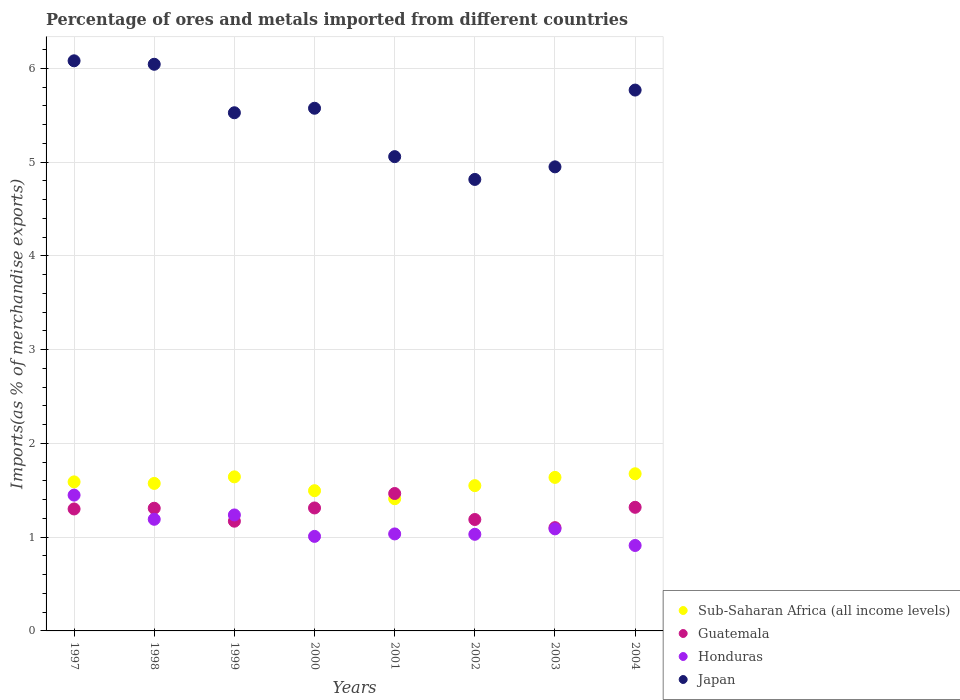What is the percentage of imports to different countries in Japan in 1999?
Provide a short and direct response. 5.53. Across all years, what is the maximum percentage of imports to different countries in Guatemala?
Ensure brevity in your answer.  1.47. Across all years, what is the minimum percentage of imports to different countries in Sub-Saharan Africa (all income levels)?
Ensure brevity in your answer.  1.41. In which year was the percentage of imports to different countries in Japan maximum?
Provide a short and direct response. 1997. In which year was the percentage of imports to different countries in Japan minimum?
Offer a terse response. 2002. What is the total percentage of imports to different countries in Guatemala in the graph?
Offer a terse response. 10.16. What is the difference between the percentage of imports to different countries in Japan in 1999 and that in 2001?
Offer a very short reply. 0.47. What is the difference between the percentage of imports to different countries in Honduras in 2004 and the percentage of imports to different countries in Japan in 1997?
Offer a terse response. -5.17. What is the average percentage of imports to different countries in Honduras per year?
Give a very brief answer. 1.12. In the year 2004, what is the difference between the percentage of imports to different countries in Honduras and percentage of imports to different countries in Sub-Saharan Africa (all income levels)?
Make the answer very short. -0.76. In how many years, is the percentage of imports to different countries in Sub-Saharan Africa (all income levels) greater than 1.6 %?
Keep it short and to the point. 3. What is the ratio of the percentage of imports to different countries in Honduras in 1998 to that in 2001?
Your answer should be compact. 1.15. Is the difference between the percentage of imports to different countries in Honduras in 2000 and 2002 greater than the difference between the percentage of imports to different countries in Sub-Saharan Africa (all income levels) in 2000 and 2002?
Your answer should be compact. Yes. What is the difference between the highest and the second highest percentage of imports to different countries in Honduras?
Make the answer very short. 0.21. What is the difference between the highest and the lowest percentage of imports to different countries in Japan?
Provide a succinct answer. 1.27. In how many years, is the percentage of imports to different countries in Honduras greater than the average percentage of imports to different countries in Honduras taken over all years?
Provide a succinct answer. 3. Is the sum of the percentage of imports to different countries in Japan in 1997 and 2004 greater than the maximum percentage of imports to different countries in Honduras across all years?
Your answer should be very brief. Yes. Is the percentage of imports to different countries in Japan strictly greater than the percentage of imports to different countries in Sub-Saharan Africa (all income levels) over the years?
Ensure brevity in your answer.  Yes. Is the percentage of imports to different countries in Sub-Saharan Africa (all income levels) strictly less than the percentage of imports to different countries in Honduras over the years?
Provide a short and direct response. No. How many years are there in the graph?
Give a very brief answer. 8. Are the values on the major ticks of Y-axis written in scientific E-notation?
Your response must be concise. No. Does the graph contain any zero values?
Ensure brevity in your answer.  No. Where does the legend appear in the graph?
Provide a short and direct response. Bottom right. How many legend labels are there?
Make the answer very short. 4. What is the title of the graph?
Ensure brevity in your answer.  Percentage of ores and metals imported from different countries. Does "Mali" appear as one of the legend labels in the graph?
Make the answer very short. No. What is the label or title of the X-axis?
Provide a succinct answer. Years. What is the label or title of the Y-axis?
Your answer should be compact. Imports(as % of merchandise exports). What is the Imports(as % of merchandise exports) in Sub-Saharan Africa (all income levels) in 1997?
Make the answer very short. 1.59. What is the Imports(as % of merchandise exports) in Guatemala in 1997?
Make the answer very short. 1.3. What is the Imports(as % of merchandise exports) of Honduras in 1997?
Your answer should be very brief. 1.45. What is the Imports(as % of merchandise exports) in Japan in 1997?
Keep it short and to the point. 6.08. What is the Imports(as % of merchandise exports) in Sub-Saharan Africa (all income levels) in 1998?
Your response must be concise. 1.57. What is the Imports(as % of merchandise exports) of Guatemala in 1998?
Give a very brief answer. 1.31. What is the Imports(as % of merchandise exports) in Honduras in 1998?
Your response must be concise. 1.19. What is the Imports(as % of merchandise exports) of Japan in 1998?
Your response must be concise. 6.04. What is the Imports(as % of merchandise exports) in Sub-Saharan Africa (all income levels) in 1999?
Provide a short and direct response. 1.64. What is the Imports(as % of merchandise exports) of Guatemala in 1999?
Your answer should be compact. 1.17. What is the Imports(as % of merchandise exports) in Honduras in 1999?
Keep it short and to the point. 1.24. What is the Imports(as % of merchandise exports) of Japan in 1999?
Your answer should be compact. 5.53. What is the Imports(as % of merchandise exports) in Sub-Saharan Africa (all income levels) in 2000?
Provide a short and direct response. 1.5. What is the Imports(as % of merchandise exports) in Guatemala in 2000?
Provide a short and direct response. 1.31. What is the Imports(as % of merchandise exports) of Honduras in 2000?
Give a very brief answer. 1.01. What is the Imports(as % of merchandise exports) in Japan in 2000?
Offer a terse response. 5.57. What is the Imports(as % of merchandise exports) in Sub-Saharan Africa (all income levels) in 2001?
Your answer should be compact. 1.41. What is the Imports(as % of merchandise exports) in Guatemala in 2001?
Ensure brevity in your answer.  1.47. What is the Imports(as % of merchandise exports) in Honduras in 2001?
Offer a terse response. 1.03. What is the Imports(as % of merchandise exports) in Japan in 2001?
Offer a very short reply. 5.06. What is the Imports(as % of merchandise exports) of Sub-Saharan Africa (all income levels) in 2002?
Your response must be concise. 1.55. What is the Imports(as % of merchandise exports) of Guatemala in 2002?
Your answer should be compact. 1.19. What is the Imports(as % of merchandise exports) of Honduras in 2002?
Give a very brief answer. 1.03. What is the Imports(as % of merchandise exports) of Japan in 2002?
Offer a terse response. 4.82. What is the Imports(as % of merchandise exports) in Sub-Saharan Africa (all income levels) in 2003?
Ensure brevity in your answer.  1.64. What is the Imports(as % of merchandise exports) in Guatemala in 2003?
Offer a terse response. 1.1. What is the Imports(as % of merchandise exports) of Honduras in 2003?
Make the answer very short. 1.09. What is the Imports(as % of merchandise exports) of Japan in 2003?
Keep it short and to the point. 4.95. What is the Imports(as % of merchandise exports) of Sub-Saharan Africa (all income levels) in 2004?
Offer a terse response. 1.68. What is the Imports(as % of merchandise exports) in Guatemala in 2004?
Provide a short and direct response. 1.32. What is the Imports(as % of merchandise exports) in Honduras in 2004?
Make the answer very short. 0.91. What is the Imports(as % of merchandise exports) in Japan in 2004?
Ensure brevity in your answer.  5.77. Across all years, what is the maximum Imports(as % of merchandise exports) of Sub-Saharan Africa (all income levels)?
Your answer should be compact. 1.68. Across all years, what is the maximum Imports(as % of merchandise exports) of Guatemala?
Provide a succinct answer. 1.47. Across all years, what is the maximum Imports(as % of merchandise exports) in Honduras?
Provide a succinct answer. 1.45. Across all years, what is the maximum Imports(as % of merchandise exports) in Japan?
Offer a terse response. 6.08. Across all years, what is the minimum Imports(as % of merchandise exports) in Sub-Saharan Africa (all income levels)?
Give a very brief answer. 1.41. Across all years, what is the minimum Imports(as % of merchandise exports) in Guatemala?
Make the answer very short. 1.1. Across all years, what is the minimum Imports(as % of merchandise exports) in Honduras?
Make the answer very short. 0.91. Across all years, what is the minimum Imports(as % of merchandise exports) in Japan?
Your response must be concise. 4.82. What is the total Imports(as % of merchandise exports) of Sub-Saharan Africa (all income levels) in the graph?
Give a very brief answer. 12.57. What is the total Imports(as % of merchandise exports) in Guatemala in the graph?
Your response must be concise. 10.16. What is the total Imports(as % of merchandise exports) of Honduras in the graph?
Keep it short and to the point. 8.95. What is the total Imports(as % of merchandise exports) in Japan in the graph?
Make the answer very short. 43.82. What is the difference between the Imports(as % of merchandise exports) in Sub-Saharan Africa (all income levels) in 1997 and that in 1998?
Provide a short and direct response. 0.02. What is the difference between the Imports(as % of merchandise exports) of Guatemala in 1997 and that in 1998?
Offer a very short reply. -0.01. What is the difference between the Imports(as % of merchandise exports) in Honduras in 1997 and that in 1998?
Make the answer very short. 0.26. What is the difference between the Imports(as % of merchandise exports) in Japan in 1997 and that in 1998?
Your answer should be compact. 0.04. What is the difference between the Imports(as % of merchandise exports) in Sub-Saharan Africa (all income levels) in 1997 and that in 1999?
Your response must be concise. -0.05. What is the difference between the Imports(as % of merchandise exports) of Guatemala in 1997 and that in 1999?
Ensure brevity in your answer.  0.13. What is the difference between the Imports(as % of merchandise exports) of Honduras in 1997 and that in 1999?
Provide a short and direct response. 0.21. What is the difference between the Imports(as % of merchandise exports) in Japan in 1997 and that in 1999?
Your answer should be very brief. 0.55. What is the difference between the Imports(as % of merchandise exports) of Sub-Saharan Africa (all income levels) in 1997 and that in 2000?
Keep it short and to the point. 0.09. What is the difference between the Imports(as % of merchandise exports) of Guatemala in 1997 and that in 2000?
Make the answer very short. -0.01. What is the difference between the Imports(as % of merchandise exports) in Honduras in 1997 and that in 2000?
Your answer should be very brief. 0.44. What is the difference between the Imports(as % of merchandise exports) of Japan in 1997 and that in 2000?
Provide a succinct answer. 0.51. What is the difference between the Imports(as % of merchandise exports) of Sub-Saharan Africa (all income levels) in 1997 and that in 2001?
Offer a very short reply. 0.18. What is the difference between the Imports(as % of merchandise exports) of Guatemala in 1997 and that in 2001?
Your response must be concise. -0.16. What is the difference between the Imports(as % of merchandise exports) in Honduras in 1997 and that in 2001?
Provide a succinct answer. 0.41. What is the difference between the Imports(as % of merchandise exports) of Guatemala in 1997 and that in 2002?
Your answer should be compact. 0.11. What is the difference between the Imports(as % of merchandise exports) in Honduras in 1997 and that in 2002?
Your response must be concise. 0.42. What is the difference between the Imports(as % of merchandise exports) of Japan in 1997 and that in 2002?
Provide a succinct answer. 1.27. What is the difference between the Imports(as % of merchandise exports) in Sub-Saharan Africa (all income levels) in 1997 and that in 2003?
Your answer should be compact. -0.05. What is the difference between the Imports(as % of merchandise exports) of Guatemala in 1997 and that in 2003?
Your answer should be very brief. 0.2. What is the difference between the Imports(as % of merchandise exports) of Honduras in 1997 and that in 2003?
Make the answer very short. 0.36. What is the difference between the Imports(as % of merchandise exports) in Japan in 1997 and that in 2003?
Your response must be concise. 1.13. What is the difference between the Imports(as % of merchandise exports) of Sub-Saharan Africa (all income levels) in 1997 and that in 2004?
Offer a terse response. -0.09. What is the difference between the Imports(as % of merchandise exports) in Guatemala in 1997 and that in 2004?
Offer a very short reply. -0.02. What is the difference between the Imports(as % of merchandise exports) in Honduras in 1997 and that in 2004?
Make the answer very short. 0.54. What is the difference between the Imports(as % of merchandise exports) of Japan in 1997 and that in 2004?
Offer a very short reply. 0.31. What is the difference between the Imports(as % of merchandise exports) in Sub-Saharan Africa (all income levels) in 1998 and that in 1999?
Provide a succinct answer. -0.07. What is the difference between the Imports(as % of merchandise exports) in Guatemala in 1998 and that in 1999?
Ensure brevity in your answer.  0.14. What is the difference between the Imports(as % of merchandise exports) in Honduras in 1998 and that in 1999?
Keep it short and to the point. -0.05. What is the difference between the Imports(as % of merchandise exports) in Japan in 1998 and that in 1999?
Your response must be concise. 0.52. What is the difference between the Imports(as % of merchandise exports) in Sub-Saharan Africa (all income levels) in 1998 and that in 2000?
Make the answer very short. 0.08. What is the difference between the Imports(as % of merchandise exports) in Guatemala in 1998 and that in 2000?
Give a very brief answer. -0. What is the difference between the Imports(as % of merchandise exports) in Honduras in 1998 and that in 2000?
Offer a very short reply. 0.18. What is the difference between the Imports(as % of merchandise exports) in Japan in 1998 and that in 2000?
Offer a very short reply. 0.47. What is the difference between the Imports(as % of merchandise exports) in Sub-Saharan Africa (all income levels) in 1998 and that in 2001?
Give a very brief answer. 0.16. What is the difference between the Imports(as % of merchandise exports) in Guatemala in 1998 and that in 2001?
Your answer should be very brief. -0.16. What is the difference between the Imports(as % of merchandise exports) of Honduras in 1998 and that in 2001?
Keep it short and to the point. 0.16. What is the difference between the Imports(as % of merchandise exports) in Sub-Saharan Africa (all income levels) in 1998 and that in 2002?
Keep it short and to the point. 0.02. What is the difference between the Imports(as % of merchandise exports) of Guatemala in 1998 and that in 2002?
Keep it short and to the point. 0.12. What is the difference between the Imports(as % of merchandise exports) in Honduras in 1998 and that in 2002?
Keep it short and to the point. 0.16. What is the difference between the Imports(as % of merchandise exports) of Japan in 1998 and that in 2002?
Provide a succinct answer. 1.23. What is the difference between the Imports(as % of merchandise exports) of Sub-Saharan Africa (all income levels) in 1998 and that in 2003?
Your answer should be compact. -0.06. What is the difference between the Imports(as % of merchandise exports) in Guatemala in 1998 and that in 2003?
Your response must be concise. 0.21. What is the difference between the Imports(as % of merchandise exports) in Honduras in 1998 and that in 2003?
Offer a very short reply. 0.1. What is the difference between the Imports(as % of merchandise exports) in Japan in 1998 and that in 2003?
Make the answer very short. 1.09. What is the difference between the Imports(as % of merchandise exports) in Sub-Saharan Africa (all income levels) in 1998 and that in 2004?
Provide a short and direct response. -0.1. What is the difference between the Imports(as % of merchandise exports) in Guatemala in 1998 and that in 2004?
Keep it short and to the point. -0.01. What is the difference between the Imports(as % of merchandise exports) in Honduras in 1998 and that in 2004?
Keep it short and to the point. 0.28. What is the difference between the Imports(as % of merchandise exports) in Japan in 1998 and that in 2004?
Offer a very short reply. 0.28. What is the difference between the Imports(as % of merchandise exports) of Sub-Saharan Africa (all income levels) in 1999 and that in 2000?
Offer a terse response. 0.15. What is the difference between the Imports(as % of merchandise exports) in Guatemala in 1999 and that in 2000?
Offer a very short reply. -0.14. What is the difference between the Imports(as % of merchandise exports) of Honduras in 1999 and that in 2000?
Offer a very short reply. 0.23. What is the difference between the Imports(as % of merchandise exports) of Japan in 1999 and that in 2000?
Provide a short and direct response. -0.05. What is the difference between the Imports(as % of merchandise exports) of Sub-Saharan Africa (all income levels) in 1999 and that in 2001?
Your answer should be compact. 0.23. What is the difference between the Imports(as % of merchandise exports) of Guatemala in 1999 and that in 2001?
Provide a short and direct response. -0.3. What is the difference between the Imports(as % of merchandise exports) of Honduras in 1999 and that in 2001?
Your answer should be very brief. 0.2. What is the difference between the Imports(as % of merchandise exports) in Japan in 1999 and that in 2001?
Give a very brief answer. 0.47. What is the difference between the Imports(as % of merchandise exports) in Sub-Saharan Africa (all income levels) in 1999 and that in 2002?
Make the answer very short. 0.09. What is the difference between the Imports(as % of merchandise exports) of Guatemala in 1999 and that in 2002?
Make the answer very short. -0.02. What is the difference between the Imports(as % of merchandise exports) in Honduras in 1999 and that in 2002?
Keep it short and to the point. 0.21. What is the difference between the Imports(as % of merchandise exports) in Japan in 1999 and that in 2002?
Ensure brevity in your answer.  0.71. What is the difference between the Imports(as % of merchandise exports) of Sub-Saharan Africa (all income levels) in 1999 and that in 2003?
Your answer should be compact. 0.01. What is the difference between the Imports(as % of merchandise exports) of Guatemala in 1999 and that in 2003?
Your answer should be very brief. 0.07. What is the difference between the Imports(as % of merchandise exports) in Honduras in 1999 and that in 2003?
Your answer should be compact. 0.15. What is the difference between the Imports(as % of merchandise exports) in Japan in 1999 and that in 2003?
Offer a very short reply. 0.58. What is the difference between the Imports(as % of merchandise exports) of Sub-Saharan Africa (all income levels) in 1999 and that in 2004?
Offer a very short reply. -0.03. What is the difference between the Imports(as % of merchandise exports) in Guatemala in 1999 and that in 2004?
Offer a very short reply. -0.15. What is the difference between the Imports(as % of merchandise exports) in Honduras in 1999 and that in 2004?
Your answer should be compact. 0.33. What is the difference between the Imports(as % of merchandise exports) in Japan in 1999 and that in 2004?
Make the answer very short. -0.24. What is the difference between the Imports(as % of merchandise exports) in Sub-Saharan Africa (all income levels) in 2000 and that in 2001?
Make the answer very short. 0.09. What is the difference between the Imports(as % of merchandise exports) of Guatemala in 2000 and that in 2001?
Your response must be concise. -0.15. What is the difference between the Imports(as % of merchandise exports) of Honduras in 2000 and that in 2001?
Offer a very short reply. -0.03. What is the difference between the Imports(as % of merchandise exports) in Japan in 2000 and that in 2001?
Your response must be concise. 0.52. What is the difference between the Imports(as % of merchandise exports) in Sub-Saharan Africa (all income levels) in 2000 and that in 2002?
Give a very brief answer. -0.05. What is the difference between the Imports(as % of merchandise exports) in Guatemala in 2000 and that in 2002?
Provide a succinct answer. 0.12. What is the difference between the Imports(as % of merchandise exports) in Honduras in 2000 and that in 2002?
Your answer should be compact. -0.02. What is the difference between the Imports(as % of merchandise exports) in Japan in 2000 and that in 2002?
Offer a very short reply. 0.76. What is the difference between the Imports(as % of merchandise exports) in Sub-Saharan Africa (all income levels) in 2000 and that in 2003?
Ensure brevity in your answer.  -0.14. What is the difference between the Imports(as % of merchandise exports) in Guatemala in 2000 and that in 2003?
Make the answer very short. 0.21. What is the difference between the Imports(as % of merchandise exports) in Honduras in 2000 and that in 2003?
Provide a short and direct response. -0.08. What is the difference between the Imports(as % of merchandise exports) in Japan in 2000 and that in 2003?
Provide a short and direct response. 0.62. What is the difference between the Imports(as % of merchandise exports) in Sub-Saharan Africa (all income levels) in 2000 and that in 2004?
Your answer should be compact. -0.18. What is the difference between the Imports(as % of merchandise exports) in Guatemala in 2000 and that in 2004?
Keep it short and to the point. -0.01. What is the difference between the Imports(as % of merchandise exports) of Honduras in 2000 and that in 2004?
Offer a very short reply. 0.1. What is the difference between the Imports(as % of merchandise exports) in Japan in 2000 and that in 2004?
Keep it short and to the point. -0.19. What is the difference between the Imports(as % of merchandise exports) of Sub-Saharan Africa (all income levels) in 2001 and that in 2002?
Provide a short and direct response. -0.14. What is the difference between the Imports(as % of merchandise exports) in Guatemala in 2001 and that in 2002?
Your answer should be very brief. 0.28. What is the difference between the Imports(as % of merchandise exports) in Honduras in 2001 and that in 2002?
Provide a succinct answer. 0. What is the difference between the Imports(as % of merchandise exports) in Japan in 2001 and that in 2002?
Make the answer very short. 0.24. What is the difference between the Imports(as % of merchandise exports) in Sub-Saharan Africa (all income levels) in 2001 and that in 2003?
Ensure brevity in your answer.  -0.23. What is the difference between the Imports(as % of merchandise exports) in Guatemala in 2001 and that in 2003?
Offer a very short reply. 0.36. What is the difference between the Imports(as % of merchandise exports) of Honduras in 2001 and that in 2003?
Your answer should be compact. -0.05. What is the difference between the Imports(as % of merchandise exports) in Japan in 2001 and that in 2003?
Provide a succinct answer. 0.11. What is the difference between the Imports(as % of merchandise exports) in Sub-Saharan Africa (all income levels) in 2001 and that in 2004?
Offer a terse response. -0.27. What is the difference between the Imports(as % of merchandise exports) in Guatemala in 2001 and that in 2004?
Make the answer very short. 0.15. What is the difference between the Imports(as % of merchandise exports) in Honduras in 2001 and that in 2004?
Offer a very short reply. 0.12. What is the difference between the Imports(as % of merchandise exports) of Japan in 2001 and that in 2004?
Provide a succinct answer. -0.71. What is the difference between the Imports(as % of merchandise exports) of Sub-Saharan Africa (all income levels) in 2002 and that in 2003?
Your answer should be compact. -0.09. What is the difference between the Imports(as % of merchandise exports) in Guatemala in 2002 and that in 2003?
Ensure brevity in your answer.  0.09. What is the difference between the Imports(as % of merchandise exports) of Honduras in 2002 and that in 2003?
Offer a terse response. -0.06. What is the difference between the Imports(as % of merchandise exports) in Japan in 2002 and that in 2003?
Offer a very short reply. -0.13. What is the difference between the Imports(as % of merchandise exports) of Sub-Saharan Africa (all income levels) in 2002 and that in 2004?
Give a very brief answer. -0.13. What is the difference between the Imports(as % of merchandise exports) of Guatemala in 2002 and that in 2004?
Your answer should be very brief. -0.13. What is the difference between the Imports(as % of merchandise exports) of Honduras in 2002 and that in 2004?
Keep it short and to the point. 0.12. What is the difference between the Imports(as % of merchandise exports) of Japan in 2002 and that in 2004?
Keep it short and to the point. -0.95. What is the difference between the Imports(as % of merchandise exports) of Sub-Saharan Africa (all income levels) in 2003 and that in 2004?
Your response must be concise. -0.04. What is the difference between the Imports(as % of merchandise exports) of Guatemala in 2003 and that in 2004?
Your response must be concise. -0.22. What is the difference between the Imports(as % of merchandise exports) in Honduras in 2003 and that in 2004?
Keep it short and to the point. 0.18. What is the difference between the Imports(as % of merchandise exports) of Japan in 2003 and that in 2004?
Keep it short and to the point. -0.82. What is the difference between the Imports(as % of merchandise exports) in Sub-Saharan Africa (all income levels) in 1997 and the Imports(as % of merchandise exports) in Guatemala in 1998?
Provide a succinct answer. 0.28. What is the difference between the Imports(as % of merchandise exports) of Sub-Saharan Africa (all income levels) in 1997 and the Imports(as % of merchandise exports) of Honduras in 1998?
Ensure brevity in your answer.  0.4. What is the difference between the Imports(as % of merchandise exports) of Sub-Saharan Africa (all income levels) in 1997 and the Imports(as % of merchandise exports) of Japan in 1998?
Keep it short and to the point. -4.45. What is the difference between the Imports(as % of merchandise exports) in Guatemala in 1997 and the Imports(as % of merchandise exports) in Honduras in 1998?
Your response must be concise. 0.11. What is the difference between the Imports(as % of merchandise exports) of Guatemala in 1997 and the Imports(as % of merchandise exports) of Japan in 1998?
Offer a terse response. -4.74. What is the difference between the Imports(as % of merchandise exports) in Honduras in 1997 and the Imports(as % of merchandise exports) in Japan in 1998?
Offer a terse response. -4.59. What is the difference between the Imports(as % of merchandise exports) in Sub-Saharan Africa (all income levels) in 1997 and the Imports(as % of merchandise exports) in Guatemala in 1999?
Your answer should be compact. 0.42. What is the difference between the Imports(as % of merchandise exports) in Sub-Saharan Africa (all income levels) in 1997 and the Imports(as % of merchandise exports) in Honduras in 1999?
Keep it short and to the point. 0.35. What is the difference between the Imports(as % of merchandise exports) of Sub-Saharan Africa (all income levels) in 1997 and the Imports(as % of merchandise exports) of Japan in 1999?
Give a very brief answer. -3.94. What is the difference between the Imports(as % of merchandise exports) in Guatemala in 1997 and the Imports(as % of merchandise exports) in Honduras in 1999?
Give a very brief answer. 0.06. What is the difference between the Imports(as % of merchandise exports) in Guatemala in 1997 and the Imports(as % of merchandise exports) in Japan in 1999?
Your response must be concise. -4.23. What is the difference between the Imports(as % of merchandise exports) of Honduras in 1997 and the Imports(as % of merchandise exports) of Japan in 1999?
Make the answer very short. -4.08. What is the difference between the Imports(as % of merchandise exports) of Sub-Saharan Africa (all income levels) in 1997 and the Imports(as % of merchandise exports) of Guatemala in 2000?
Ensure brevity in your answer.  0.28. What is the difference between the Imports(as % of merchandise exports) in Sub-Saharan Africa (all income levels) in 1997 and the Imports(as % of merchandise exports) in Honduras in 2000?
Offer a very short reply. 0.58. What is the difference between the Imports(as % of merchandise exports) of Sub-Saharan Africa (all income levels) in 1997 and the Imports(as % of merchandise exports) of Japan in 2000?
Give a very brief answer. -3.98. What is the difference between the Imports(as % of merchandise exports) of Guatemala in 1997 and the Imports(as % of merchandise exports) of Honduras in 2000?
Your response must be concise. 0.29. What is the difference between the Imports(as % of merchandise exports) in Guatemala in 1997 and the Imports(as % of merchandise exports) in Japan in 2000?
Provide a short and direct response. -4.27. What is the difference between the Imports(as % of merchandise exports) of Honduras in 1997 and the Imports(as % of merchandise exports) of Japan in 2000?
Ensure brevity in your answer.  -4.13. What is the difference between the Imports(as % of merchandise exports) in Sub-Saharan Africa (all income levels) in 1997 and the Imports(as % of merchandise exports) in Guatemala in 2001?
Make the answer very short. 0.12. What is the difference between the Imports(as % of merchandise exports) in Sub-Saharan Africa (all income levels) in 1997 and the Imports(as % of merchandise exports) in Honduras in 2001?
Your answer should be compact. 0.56. What is the difference between the Imports(as % of merchandise exports) in Sub-Saharan Africa (all income levels) in 1997 and the Imports(as % of merchandise exports) in Japan in 2001?
Provide a succinct answer. -3.47. What is the difference between the Imports(as % of merchandise exports) of Guatemala in 1997 and the Imports(as % of merchandise exports) of Honduras in 2001?
Provide a short and direct response. 0.27. What is the difference between the Imports(as % of merchandise exports) of Guatemala in 1997 and the Imports(as % of merchandise exports) of Japan in 2001?
Offer a terse response. -3.76. What is the difference between the Imports(as % of merchandise exports) in Honduras in 1997 and the Imports(as % of merchandise exports) in Japan in 2001?
Provide a short and direct response. -3.61. What is the difference between the Imports(as % of merchandise exports) of Sub-Saharan Africa (all income levels) in 1997 and the Imports(as % of merchandise exports) of Guatemala in 2002?
Make the answer very short. 0.4. What is the difference between the Imports(as % of merchandise exports) in Sub-Saharan Africa (all income levels) in 1997 and the Imports(as % of merchandise exports) in Honduras in 2002?
Make the answer very short. 0.56. What is the difference between the Imports(as % of merchandise exports) in Sub-Saharan Africa (all income levels) in 1997 and the Imports(as % of merchandise exports) in Japan in 2002?
Your response must be concise. -3.23. What is the difference between the Imports(as % of merchandise exports) of Guatemala in 1997 and the Imports(as % of merchandise exports) of Honduras in 2002?
Offer a terse response. 0.27. What is the difference between the Imports(as % of merchandise exports) of Guatemala in 1997 and the Imports(as % of merchandise exports) of Japan in 2002?
Make the answer very short. -3.51. What is the difference between the Imports(as % of merchandise exports) in Honduras in 1997 and the Imports(as % of merchandise exports) in Japan in 2002?
Offer a very short reply. -3.37. What is the difference between the Imports(as % of merchandise exports) in Sub-Saharan Africa (all income levels) in 1997 and the Imports(as % of merchandise exports) in Guatemala in 2003?
Provide a succinct answer. 0.49. What is the difference between the Imports(as % of merchandise exports) in Sub-Saharan Africa (all income levels) in 1997 and the Imports(as % of merchandise exports) in Honduras in 2003?
Offer a terse response. 0.5. What is the difference between the Imports(as % of merchandise exports) in Sub-Saharan Africa (all income levels) in 1997 and the Imports(as % of merchandise exports) in Japan in 2003?
Offer a very short reply. -3.36. What is the difference between the Imports(as % of merchandise exports) in Guatemala in 1997 and the Imports(as % of merchandise exports) in Honduras in 2003?
Ensure brevity in your answer.  0.21. What is the difference between the Imports(as % of merchandise exports) of Guatemala in 1997 and the Imports(as % of merchandise exports) of Japan in 2003?
Provide a short and direct response. -3.65. What is the difference between the Imports(as % of merchandise exports) of Honduras in 1997 and the Imports(as % of merchandise exports) of Japan in 2003?
Ensure brevity in your answer.  -3.5. What is the difference between the Imports(as % of merchandise exports) in Sub-Saharan Africa (all income levels) in 1997 and the Imports(as % of merchandise exports) in Guatemala in 2004?
Your answer should be very brief. 0.27. What is the difference between the Imports(as % of merchandise exports) of Sub-Saharan Africa (all income levels) in 1997 and the Imports(as % of merchandise exports) of Honduras in 2004?
Your answer should be very brief. 0.68. What is the difference between the Imports(as % of merchandise exports) of Sub-Saharan Africa (all income levels) in 1997 and the Imports(as % of merchandise exports) of Japan in 2004?
Your answer should be compact. -4.18. What is the difference between the Imports(as % of merchandise exports) in Guatemala in 1997 and the Imports(as % of merchandise exports) in Honduras in 2004?
Give a very brief answer. 0.39. What is the difference between the Imports(as % of merchandise exports) of Guatemala in 1997 and the Imports(as % of merchandise exports) of Japan in 2004?
Your response must be concise. -4.47. What is the difference between the Imports(as % of merchandise exports) in Honduras in 1997 and the Imports(as % of merchandise exports) in Japan in 2004?
Keep it short and to the point. -4.32. What is the difference between the Imports(as % of merchandise exports) in Sub-Saharan Africa (all income levels) in 1998 and the Imports(as % of merchandise exports) in Guatemala in 1999?
Keep it short and to the point. 0.4. What is the difference between the Imports(as % of merchandise exports) of Sub-Saharan Africa (all income levels) in 1998 and the Imports(as % of merchandise exports) of Honduras in 1999?
Make the answer very short. 0.34. What is the difference between the Imports(as % of merchandise exports) in Sub-Saharan Africa (all income levels) in 1998 and the Imports(as % of merchandise exports) in Japan in 1999?
Keep it short and to the point. -3.95. What is the difference between the Imports(as % of merchandise exports) in Guatemala in 1998 and the Imports(as % of merchandise exports) in Honduras in 1999?
Provide a succinct answer. 0.07. What is the difference between the Imports(as % of merchandise exports) of Guatemala in 1998 and the Imports(as % of merchandise exports) of Japan in 1999?
Offer a very short reply. -4.22. What is the difference between the Imports(as % of merchandise exports) in Honduras in 1998 and the Imports(as % of merchandise exports) in Japan in 1999?
Your answer should be very brief. -4.34. What is the difference between the Imports(as % of merchandise exports) in Sub-Saharan Africa (all income levels) in 1998 and the Imports(as % of merchandise exports) in Guatemala in 2000?
Offer a very short reply. 0.26. What is the difference between the Imports(as % of merchandise exports) of Sub-Saharan Africa (all income levels) in 1998 and the Imports(as % of merchandise exports) of Honduras in 2000?
Keep it short and to the point. 0.56. What is the difference between the Imports(as % of merchandise exports) of Sub-Saharan Africa (all income levels) in 1998 and the Imports(as % of merchandise exports) of Japan in 2000?
Offer a very short reply. -4. What is the difference between the Imports(as % of merchandise exports) of Guatemala in 1998 and the Imports(as % of merchandise exports) of Honduras in 2000?
Offer a very short reply. 0.3. What is the difference between the Imports(as % of merchandise exports) of Guatemala in 1998 and the Imports(as % of merchandise exports) of Japan in 2000?
Your answer should be compact. -4.27. What is the difference between the Imports(as % of merchandise exports) of Honduras in 1998 and the Imports(as % of merchandise exports) of Japan in 2000?
Provide a succinct answer. -4.38. What is the difference between the Imports(as % of merchandise exports) in Sub-Saharan Africa (all income levels) in 1998 and the Imports(as % of merchandise exports) in Guatemala in 2001?
Ensure brevity in your answer.  0.11. What is the difference between the Imports(as % of merchandise exports) of Sub-Saharan Africa (all income levels) in 1998 and the Imports(as % of merchandise exports) of Honduras in 2001?
Ensure brevity in your answer.  0.54. What is the difference between the Imports(as % of merchandise exports) of Sub-Saharan Africa (all income levels) in 1998 and the Imports(as % of merchandise exports) of Japan in 2001?
Make the answer very short. -3.49. What is the difference between the Imports(as % of merchandise exports) of Guatemala in 1998 and the Imports(as % of merchandise exports) of Honduras in 2001?
Offer a terse response. 0.27. What is the difference between the Imports(as % of merchandise exports) of Guatemala in 1998 and the Imports(as % of merchandise exports) of Japan in 2001?
Make the answer very short. -3.75. What is the difference between the Imports(as % of merchandise exports) of Honduras in 1998 and the Imports(as % of merchandise exports) of Japan in 2001?
Your answer should be compact. -3.87. What is the difference between the Imports(as % of merchandise exports) in Sub-Saharan Africa (all income levels) in 1998 and the Imports(as % of merchandise exports) in Guatemala in 2002?
Offer a very short reply. 0.38. What is the difference between the Imports(as % of merchandise exports) in Sub-Saharan Africa (all income levels) in 1998 and the Imports(as % of merchandise exports) in Honduras in 2002?
Provide a short and direct response. 0.54. What is the difference between the Imports(as % of merchandise exports) of Sub-Saharan Africa (all income levels) in 1998 and the Imports(as % of merchandise exports) of Japan in 2002?
Ensure brevity in your answer.  -3.24. What is the difference between the Imports(as % of merchandise exports) in Guatemala in 1998 and the Imports(as % of merchandise exports) in Honduras in 2002?
Offer a very short reply. 0.28. What is the difference between the Imports(as % of merchandise exports) of Guatemala in 1998 and the Imports(as % of merchandise exports) of Japan in 2002?
Your response must be concise. -3.51. What is the difference between the Imports(as % of merchandise exports) of Honduras in 1998 and the Imports(as % of merchandise exports) of Japan in 2002?
Your response must be concise. -3.62. What is the difference between the Imports(as % of merchandise exports) of Sub-Saharan Africa (all income levels) in 1998 and the Imports(as % of merchandise exports) of Guatemala in 2003?
Give a very brief answer. 0.47. What is the difference between the Imports(as % of merchandise exports) of Sub-Saharan Africa (all income levels) in 1998 and the Imports(as % of merchandise exports) of Honduras in 2003?
Make the answer very short. 0.48. What is the difference between the Imports(as % of merchandise exports) of Sub-Saharan Africa (all income levels) in 1998 and the Imports(as % of merchandise exports) of Japan in 2003?
Ensure brevity in your answer.  -3.38. What is the difference between the Imports(as % of merchandise exports) in Guatemala in 1998 and the Imports(as % of merchandise exports) in Honduras in 2003?
Provide a short and direct response. 0.22. What is the difference between the Imports(as % of merchandise exports) of Guatemala in 1998 and the Imports(as % of merchandise exports) of Japan in 2003?
Give a very brief answer. -3.64. What is the difference between the Imports(as % of merchandise exports) of Honduras in 1998 and the Imports(as % of merchandise exports) of Japan in 2003?
Your answer should be compact. -3.76. What is the difference between the Imports(as % of merchandise exports) in Sub-Saharan Africa (all income levels) in 1998 and the Imports(as % of merchandise exports) in Guatemala in 2004?
Keep it short and to the point. 0.25. What is the difference between the Imports(as % of merchandise exports) in Sub-Saharan Africa (all income levels) in 1998 and the Imports(as % of merchandise exports) in Honduras in 2004?
Ensure brevity in your answer.  0.66. What is the difference between the Imports(as % of merchandise exports) of Sub-Saharan Africa (all income levels) in 1998 and the Imports(as % of merchandise exports) of Japan in 2004?
Your answer should be very brief. -4.2. What is the difference between the Imports(as % of merchandise exports) in Guatemala in 1998 and the Imports(as % of merchandise exports) in Honduras in 2004?
Provide a succinct answer. 0.4. What is the difference between the Imports(as % of merchandise exports) of Guatemala in 1998 and the Imports(as % of merchandise exports) of Japan in 2004?
Offer a terse response. -4.46. What is the difference between the Imports(as % of merchandise exports) in Honduras in 1998 and the Imports(as % of merchandise exports) in Japan in 2004?
Offer a terse response. -4.58. What is the difference between the Imports(as % of merchandise exports) of Sub-Saharan Africa (all income levels) in 1999 and the Imports(as % of merchandise exports) of Guatemala in 2000?
Keep it short and to the point. 0.33. What is the difference between the Imports(as % of merchandise exports) in Sub-Saharan Africa (all income levels) in 1999 and the Imports(as % of merchandise exports) in Honduras in 2000?
Your answer should be very brief. 0.63. What is the difference between the Imports(as % of merchandise exports) of Sub-Saharan Africa (all income levels) in 1999 and the Imports(as % of merchandise exports) of Japan in 2000?
Your answer should be compact. -3.93. What is the difference between the Imports(as % of merchandise exports) of Guatemala in 1999 and the Imports(as % of merchandise exports) of Honduras in 2000?
Your answer should be very brief. 0.16. What is the difference between the Imports(as % of merchandise exports) of Guatemala in 1999 and the Imports(as % of merchandise exports) of Japan in 2000?
Make the answer very short. -4.4. What is the difference between the Imports(as % of merchandise exports) in Honduras in 1999 and the Imports(as % of merchandise exports) in Japan in 2000?
Your answer should be very brief. -4.34. What is the difference between the Imports(as % of merchandise exports) of Sub-Saharan Africa (all income levels) in 1999 and the Imports(as % of merchandise exports) of Guatemala in 2001?
Offer a very short reply. 0.18. What is the difference between the Imports(as % of merchandise exports) of Sub-Saharan Africa (all income levels) in 1999 and the Imports(as % of merchandise exports) of Honduras in 2001?
Provide a short and direct response. 0.61. What is the difference between the Imports(as % of merchandise exports) in Sub-Saharan Africa (all income levels) in 1999 and the Imports(as % of merchandise exports) in Japan in 2001?
Give a very brief answer. -3.42. What is the difference between the Imports(as % of merchandise exports) in Guatemala in 1999 and the Imports(as % of merchandise exports) in Honduras in 2001?
Offer a terse response. 0.14. What is the difference between the Imports(as % of merchandise exports) of Guatemala in 1999 and the Imports(as % of merchandise exports) of Japan in 2001?
Provide a succinct answer. -3.89. What is the difference between the Imports(as % of merchandise exports) in Honduras in 1999 and the Imports(as % of merchandise exports) in Japan in 2001?
Offer a very short reply. -3.82. What is the difference between the Imports(as % of merchandise exports) of Sub-Saharan Africa (all income levels) in 1999 and the Imports(as % of merchandise exports) of Guatemala in 2002?
Provide a short and direct response. 0.45. What is the difference between the Imports(as % of merchandise exports) in Sub-Saharan Africa (all income levels) in 1999 and the Imports(as % of merchandise exports) in Honduras in 2002?
Ensure brevity in your answer.  0.61. What is the difference between the Imports(as % of merchandise exports) in Sub-Saharan Africa (all income levels) in 1999 and the Imports(as % of merchandise exports) in Japan in 2002?
Make the answer very short. -3.17. What is the difference between the Imports(as % of merchandise exports) in Guatemala in 1999 and the Imports(as % of merchandise exports) in Honduras in 2002?
Provide a succinct answer. 0.14. What is the difference between the Imports(as % of merchandise exports) of Guatemala in 1999 and the Imports(as % of merchandise exports) of Japan in 2002?
Keep it short and to the point. -3.64. What is the difference between the Imports(as % of merchandise exports) in Honduras in 1999 and the Imports(as % of merchandise exports) in Japan in 2002?
Your answer should be compact. -3.58. What is the difference between the Imports(as % of merchandise exports) of Sub-Saharan Africa (all income levels) in 1999 and the Imports(as % of merchandise exports) of Guatemala in 2003?
Make the answer very short. 0.54. What is the difference between the Imports(as % of merchandise exports) of Sub-Saharan Africa (all income levels) in 1999 and the Imports(as % of merchandise exports) of Honduras in 2003?
Ensure brevity in your answer.  0.55. What is the difference between the Imports(as % of merchandise exports) in Sub-Saharan Africa (all income levels) in 1999 and the Imports(as % of merchandise exports) in Japan in 2003?
Offer a very short reply. -3.31. What is the difference between the Imports(as % of merchandise exports) of Guatemala in 1999 and the Imports(as % of merchandise exports) of Honduras in 2003?
Your answer should be very brief. 0.08. What is the difference between the Imports(as % of merchandise exports) of Guatemala in 1999 and the Imports(as % of merchandise exports) of Japan in 2003?
Offer a very short reply. -3.78. What is the difference between the Imports(as % of merchandise exports) of Honduras in 1999 and the Imports(as % of merchandise exports) of Japan in 2003?
Give a very brief answer. -3.71. What is the difference between the Imports(as % of merchandise exports) in Sub-Saharan Africa (all income levels) in 1999 and the Imports(as % of merchandise exports) in Guatemala in 2004?
Your response must be concise. 0.32. What is the difference between the Imports(as % of merchandise exports) of Sub-Saharan Africa (all income levels) in 1999 and the Imports(as % of merchandise exports) of Honduras in 2004?
Provide a succinct answer. 0.73. What is the difference between the Imports(as % of merchandise exports) in Sub-Saharan Africa (all income levels) in 1999 and the Imports(as % of merchandise exports) in Japan in 2004?
Provide a short and direct response. -4.13. What is the difference between the Imports(as % of merchandise exports) of Guatemala in 1999 and the Imports(as % of merchandise exports) of Honduras in 2004?
Provide a short and direct response. 0.26. What is the difference between the Imports(as % of merchandise exports) of Guatemala in 1999 and the Imports(as % of merchandise exports) of Japan in 2004?
Offer a terse response. -4.6. What is the difference between the Imports(as % of merchandise exports) of Honduras in 1999 and the Imports(as % of merchandise exports) of Japan in 2004?
Provide a succinct answer. -4.53. What is the difference between the Imports(as % of merchandise exports) in Sub-Saharan Africa (all income levels) in 2000 and the Imports(as % of merchandise exports) in Guatemala in 2001?
Ensure brevity in your answer.  0.03. What is the difference between the Imports(as % of merchandise exports) of Sub-Saharan Africa (all income levels) in 2000 and the Imports(as % of merchandise exports) of Honduras in 2001?
Your answer should be very brief. 0.46. What is the difference between the Imports(as % of merchandise exports) in Sub-Saharan Africa (all income levels) in 2000 and the Imports(as % of merchandise exports) in Japan in 2001?
Your response must be concise. -3.56. What is the difference between the Imports(as % of merchandise exports) of Guatemala in 2000 and the Imports(as % of merchandise exports) of Honduras in 2001?
Your response must be concise. 0.28. What is the difference between the Imports(as % of merchandise exports) in Guatemala in 2000 and the Imports(as % of merchandise exports) in Japan in 2001?
Provide a succinct answer. -3.75. What is the difference between the Imports(as % of merchandise exports) of Honduras in 2000 and the Imports(as % of merchandise exports) of Japan in 2001?
Your response must be concise. -4.05. What is the difference between the Imports(as % of merchandise exports) of Sub-Saharan Africa (all income levels) in 2000 and the Imports(as % of merchandise exports) of Guatemala in 2002?
Ensure brevity in your answer.  0.31. What is the difference between the Imports(as % of merchandise exports) of Sub-Saharan Africa (all income levels) in 2000 and the Imports(as % of merchandise exports) of Honduras in 2002?
Your answer should be compact. 0.47. What is the difference between the Imports(as % of merchandise exports) in Sub-Saharan Africa (all income levels) in 2000 and the Imports(as % of merchandise exports) in Japan in 2002?
Offer a very short reply. -3.32. What is the difference between the Imports(as % of merchandise exports) in Guatemala in 2000 and the Imports(as % of merchandise exports) in Honduras in 2002?
Offer a terse response. 0.28. What is the difference between the Imports(as % of merchandise exports) of Guatemala in 2000 and the Imports(as % of merchandise exports) of Japan in 2002?
Give a very brief answer. -3.5. What is the difference between the Imports(as % of merchandise exports) in Honduras in 2000 and the Imports(as % of merchandise exports) in Japan in 2002?
Provide a succinct answer. -3.81. What is the difference between the Imports(as % of merchandise exports) of Sub-Saharan Africa (all income levels) in 2000 and the Imports(as % of merchandise exports) of Guatemala in 2003?
Your response must be concise. 0.39. What is the difference between the Imports(as % of merchandise exports) in Sub-Saharan Africa (all income levels) in 2000 and the Imports(as % of merchandise exports) in Honduras in 2003?
Make the answer very short. 0.41. What is the difference between the Imports(as % of merchandise exports) in Sub-Saharan Africa (all income levels) in 2000 and the Imports(as % of merchandise exports) in Japan in 2003?
Keep it short and to the point. -3.45. What is the difference between the Imports(as % of merchandise exports) in Guatemala in 2000 and the Imports(as % of merchandise exports) in Honduras in 2003?
Your answer should be compact. 0.22. What is the difference between the Imports(as % of merchandise exports) in Guatemala in 2000 and the Imports(as % of merchandise exports) in Japan in 2003?
Your answer should be compact. -3.64. What is the difference between the Imports(as % of merchandise exports) of Honduras in 2000 and the Imports(as % of merchandise exports) of Japan in 2003?
Keep it short and to the point. -3.94. What is the difference between the Imports(as % of merchandise exports) of Sub-Saharan Africa (all income levels) in 2000 and the Imports(as % of merchandise exports) of Guatemala in 2004?
Your answer should be compact. 0.18. What is the difference between the Imports(as % of merchandise exports) in Sub-Saharan Africa (all income levels) in 2000 and the Imports(as % of merchandise exports) in Honduras in 2004?
Provide a succinct answer. 0.58. What is the difference between the Imports(as % of merchandise exports) in Sub-Saharan Africa (all income levels) in 2000 and the Imports(as % of merchandise exports) in Japan in 2004?
Ensure brevity in your answer.  -4.27. What is the difference between the Imports(as % of merchandise exports) of Guatemala in 2000 and the Imports(as % of merchandise exports) of Japan in 2004?
Your answer should be compact. -4.46. What is the difference between the Imports(as % of merchandise exports) in Honduras in 2000 and the Imports(as % of merchandise exports) in Japan in 2004?
Make the answer very short. -4.76. What is the difference between the Imports(as % of merchandise exports) of Sub-Saharan Africa (all income levels) in 2001 and the Imports(as % of merchandise exports) of Guatemala in 2002?
Offer a very short reply. 0.22. What is the difference between the Imports(as % of merchandise exports) in Sub-Saharan Africa (all income levels) in 2001 and the Imports(as % of merchandise exports) in Honduras in 2002?
Offer a very short reply. 0.38. What is the difference between the Imports(as % of merchandise exports) of Sub-Saharan Africa (all income levels) in 2001 and the Imports(as % of merchandise exports) of Japan in 2002?
Make the answer very short. -3.41. What is the difference between the Imports(as % of merchandise exports) in Guatemala in 2001 and the Imports(as % of merchandise exports) in Honduras in 2002?
Offer a terse response. 0.44. What is the difference between the Imports(as % of merchandise exports) in Guatemala in 2001 and the Imports(as % of merchandise exports) in Japan in 2002?
Ensure brevity in your answer.  -3.35. What is the difference between the Imports(as % of merchandise exports) of Honduras in 2001 and the Imports(as % of merchandise exports) of Japan in 2002?
Your answer should be compact. -3.78. What is the difference between the Imports(as % of merchandise exports) in Sub-Saharan Africa (all income levels) in 2001 and the Imports(as % of merchandise exports) in Guatemala in 2003?
Provide a short and direct response. 0.31. What is the difference between the Imports(as % of merchandise exports) in Sub-Saharan Africa (all income levels) in 2001 and the Imports(as % of merchandise exports) in Honduras in 2003?
Your answer should be very brief. 0.32. What is the difference between the Imports(as % of merchandise exports) in Sub-Saharan Africa (all income levels) in 2001 and the Imports(as % of merchandise exports) in Japan in 2003?
Offer a very short reply. -3.54. What is the difference between the Imports(as % of merchandise exports) of Guatemala in 2001 and the Imports(as % of merchandise exports) of Honduras in 2003?
Your response must be concise. 0.38. What is the difference between the Imports(as % of merchandise exports) in Guatemala in 2001 and the Imports(as % of merchandise exports) in Japan in 2003?
Provide a short and direct response. -3.48. What is the difference between the Imports(as % of merchandise exports) in Honduras in 2001 and the Imports(as % of merchandise exports) in Japan in 2003?
Offer a very short reply. -3.91. What is the difference between the Imports(as % of merchandise exports) of Sub-Saharan Africa (all income levels) in 2001 and the Imports(as % of merchandise exports) of Guatemala in 2004?
Your response must be concise. 0.09. What is the difference between the Imports(as % of merchandise exports) of Sub-Saharan Africa (all income levels) in 2001 and the Imports(as % of merchandise exports) of Honduras in 2004?
Provide a succinct answer. 0.5. What is the difference between the Imports(as % of merchandise exports) of Sub-Saharan Africa (all income levels) in 2001 and the Imports(as % of merchandise exports) of Japan in 2004?
Your response must be concise. -4.36. What is the difference between the Imports(as % of merchandise exports) in Guatemala in 2001 and the Imports(as % of merchandise exports) in Honduras in 2004?
Provide a short and direct response. 0.55. What is the difference between the Imports(as % of merchandise exports) in Guatemala in 2001 and the Imports(as % of merchandise exports) in Japan in 2004?
Offer a very short reply. -4.3. What is the difference between the Imports(as % of merchandise exports) in Honduras in 2001 and the Imports(as % of merchandise exports) in Japan in 2004?
Keep it short and to the point. -4.73. What is the difference between the Imports(as % of merchandise exports) of Sub-Saharan Africa (all income levels) in 2002 and the Imports(as % of merchandise exports) of Guatemala in 2003?
Your response must be concise. 0.45. What is the difference between the Imports(as % of merchandise exports) in Sub-Saharan Africa (all income levels) in 2002 and the Imports(as % of merchandise exports) in Honduras in 2003?
Your response must be concise. 0.46. What is the difference between the Imports(as % of merchandise exports) in Sub-Saharan Africa (all income levels) in 2002 and the Imports(as % of merchandise exports) in Japan in 2003?
Provide a succinct answer. -3.4. What is the difference between the Imports(as % of merchandise exports) of Guatemala in 2002 and the Imports(as % of merchandise exports) of Honduras in 2003?
Ensure brevity in your answer.  0.1. What is the difference between the Imports(as % of merchandise exports) in Guatemala in 2002 and the Imports(as % of merchandise exports) in Japan in 2003?
Ensure brevity in your answer.  -3.76. What is the difference between the Imports(as % of merchandise exports) of Honduras in 2002 and the Imports(as % of merchandise exports) of Japan in 2003?
Offer a very short reply. -3.92. What is the difference between the Imports(as % of merchandise exports) in Sub-Saharan Africa (all income levels) in 2002 and the Imports(as % of merchandise exports) in Guatemala in 2004?
Your answer should be compact. 0.23. What is the difference between the Imports(as % of merchandise exports) in Sub-Saharan Africa (all income levels) in 2002 and the Imports(as % of merchandise exports) in Honduras in 2004?
Make the answer very short. 0.64. What is the difference between the Imports(as % of merchandise exports) in Sub-Saharan Africa (all income levels) in 2002 and the Imports(as % of merchandise exports) in Japan in 2004?
Your answer should be very brief. -4.22. What is the difference between the Imports(as % of merchandise exports) of Guatemala in 2002 and the Imports(as % of merchandise exports) of Honduras in 2004?
Your answer should be compact. 0.28. What is the difference between the Imports(as % of merchandise exports) of Guatemala in 2002 and the Imports(as % of merchandise exports) of Japan in 2004?
Your answer should be very brief. -4.58. What is the difference between the Imports(as % of merchandise exports) in Honduras in 2002 and the Imports(as % of merchandise exports) in Japan in 2004?
Your response must be concise. -4.74. What is the difference between the Imports(as % of merchandise exports) in Sub-Saharan Africa (all income levels) in 2003 and the Imports(as % of merchandise exports) in Guatemala in 2004?
Your answer should be very brief. 0.32. What is the difference between the Imports(as % of merchandise exports) in Sub-Saharan Africa (all income levels) in 2003 and the Imports(as % of merchandise exports) in Honduras in 2004?
Your response must be concise. 0.73. What is the difference between the Imports(as % of merchandise exports) in Sub-Saharan Africa (all income levels) in 2003 and the Imports(as % of merchandise exports) in Japan in 2004?
Offer a terse response. -4.13. What is the difference between the Imports(as % of merchandise exports) of Guatemala in 2003 and the Imports(as % of merchandise exports) of Honduras in 2004?
Keep it short and to the point. 0.19. What is the difference between the Imports(as % of merchandise exports) in Guatemala in 2003 and the Imports(as % of merchandise exports) in Japan in 2004?
Your response must be concise. -4.67. What is the difference between the Imports(as % of merchandise exports) of Honduras in 2003 and the Imports(as % of merchandise exports) of Japan in 2004?
Your response must be concise. -4.68. What is the average Imports(as % of merchandise exports) in Sub-Saharan Africa (all income levels) per year?
Give a very brief answer. 1.57. What is the average Imports(as % of merchandise exports) in Guatemala per year?
Offer a very short reply. 1.27. What is the average Imports(as % of merchandise exports) in Honduras per year?
Offer a terse response. 1.12. What is the average Imports(as % of merchandise exports) in Japan per year?
Your answer should be very brief. 5.48. In the year 1997, what is the difference between the Imports(as % of merchandise exports) in Sub-Saharan Africa (all income levels) and Imports(as % of merchandise exports) in Guatemala?
Your response must be concise. 0.29. In the year 1997, what is the difference between the Imports(as % of merchandise exports) in Sub-Saharan Africa (all income levels) and Imports(as % of merchandise exports) in Honduras?
Your response must be concise. 0.14. In the year 1997, what is the difference between the Imports(as % of merchandise exports) in Sub-Saharan Africa (all income levels) and Imports(as % of merchandise exports) in Japan?
Provide a succinct answer. -4.49. In the year 1997, what is the difference between the Imports(as % of merchandise exports) in Guatemala and Imports(as % of merchandise exports) in Honduras?
Keep it short and to the point. -0.15. In the year 1997, what is the difference between the Imports(as % of merchandise exports) in Guatemala and Imports(as % of merchandise exports) in Japan?
Make the answer very short. -4.78. In the year 1997, what is the difference between the Imports(as % of merchandise exports) in Honduras and Imports(as % of merchandise exports) in Japan?
Provide a short and direct response. -4.63. In the year 1998, what is the difference between the Imports(as % of merchandise exports) in Sub-Saharan Africa (all income levels) and Imports(as % of merchandise exports) in Guatemala?
Ensure brevity in your answer.  0.26. In the year 1998, what is the difference between the Imports(as % of merchandise exports) in Sub-Saharan Africa (all income levels) and Imports(as % of merchandise exports) in Honduras?
Make the answer very short. 0.38. In the year 1998, what is the difference between the Imports(as % of merchandise exports) in Sub-Saharan Africa (all income levels) and Imports(as % of merchandise exports) in Japan?
Your response must be concise. -4.47. In the year 1998, what is the difference between the Imports(as % of merchandise exports) in Guatemala and Imports(as % of merchandise exports) in Honduras?
Ensure brevity in your answer.  0.12. In the year 1998, what is the difference between the Imports(as % of merchandise exports) in Guatemala and Imports(as % of merchandise exports) in Japan?
Make the answer very short. -4.73. In the year 1998, what is the difference between the Imports(as % of merchandise exports) of Honduras and Imports(as % of merchandise exports) of Japan?
Your answer should be compact. -4.85. In the year 1999, what is the difference between the Imports(as % of merchandise exports) of Sub-Saharan Africa (all income levels) and Imports(as % of merchandise exports) of Guatemala?
Provide a succinct answer. 0.47. In the year 1999, what is the difference between the Imports(as % of merchandise exports) of Sub-Saharan Africa (all income levels) and Imports(as % of merchandise exports) of Honduras?
Keep it short and to the point. 0.41. In the year 1999, what is the difference between the Imports(as % of merchandise exports) of Sub-Saharan Africa (all income levels) and Imports(as % of merchandise exports) of Japan?
Ensure brevity in your answer.  -3.88. In the year 1999, what is the difference between the Imports(as % of merchandise exports) of Guatemala and Imports(as % of merchandise exports) of Honduras?
Make the answer very short. -0.07. In the year 1999, what is the difference between the Imports(as % of merchandise exports) of Guatemala and Imports(as % of merchandise exports) of Japan?
Offer a terse response. -4.36. In the year 1999, what is the difference between the Imports(as % of merchandise exports) of Honduras and Imports(as % of merchandise exports) of Japan?
Your answer should be compact. -4.29. In the year 2000, what is the difference between the Imports(as % of merchandise exports) of Sub-Saharan Africa (all income levels) and Imports(as % of merchandise exports) of Guatemala?
Provide a short and direct response. 0.18. In the year 2000, what is the difference between the Imports(as % of merchandise exports) of Sub-Saharan Africa (all income levels) and Imports(as % of merchandise exports) of Honduras?
Your answer should be compact. 0.49. In the year 2000, what is the difference between the Imports(as % of merchandise exports) of Sub-Saharan Africa (all income levels) and Imports(as % of merchandise exports) of Japan?
Ensure brevity in your answer.  -4.08. In the year 2000, what is the difference between the Imports(as % of merchandise exports) in Guatemala and Imports(as % of merchandise exports) in Honduras?
Offer a very short reply. 0.3. In the year 2000, what is the difference between the Imports(as % of merchandise exports) in Guatemala and Imports(as % of merchandise exports) in Japan?
Ensure brevity in your answer.  -4.26. In the year 2000, what is the difference between the Imports(as % of merchandise exports) in Honduras and Imports(as % of merchandise exports) in Japan?
Provide a succinct answer. -4.57. In the year 2001, what is the difference between the Imports(as % of merchandise exports) in Sub-Saharan Africa (all income levels) and Imports(as % of merchandise exports) in Guatemala?
Provide a short and direct response. -0.06. In the year 2001, what is the difference between the Imports(as % of merchandise exports) of Sub-Saharan Africa (all income levels) and Imports(as % of merchandise exports) of Honduras?
Your response must be concise. 0.38. In the year 2001, what is the difference between the Imports(as % of merchandise exports) in Sub-Saharan Africa (all income levels) and Imports(as % of merchandise exports) in Japan?
Give a very brief answer. -3.65. In the year 2001, what is the difference between the Imports(as % of merchandise exports) in Guatemala and Imports(as % of merchandise exports) in Honduras?
Make the answer very short. 0.43. In the year 2001, what is the difference between the Imports(as % of merchandise exports) in Guatemala and Imports(as % of merchandise exports) in Japan?
Give a very brief answer. -3.59. In the year 2001, what is the difference between the Imports(as % of merchandise exports) in Honduras and Imports(as % of merchandise exports) in Japan?
Offer a very short reply. -4.02. In the year 2002, what is the difference between the Imports(as % of merchandise exports) in Sub-Saharan Africa (all income levels) and Imports(as % of merchandise exports) in Guatemala?
Provide a succinct answer. 0.36. In the year 2002, what is the difference between the Imports(as % of merchandise exports) in Sub-Saharan Africa (all income levels) and Imports(as % of merchandise exports) in Honduras?
Provide a succinct answer. 0.52. In the year 2002, what is the difference between the Imports(as % of merchandise exports) of Sub-Saharan Africa (all income levels) and Imports(as % of merchandise exports) of Japan?
Your response must be concise. -3.27. In the year 2002, what is the difference between the Imports(as % of merchandise exports) of Guatemala and Imports(as % of merchandise exports) of Honduras?
Provide a succinct answer. 0.16. In the year 2002, what is the difference between the Imports(as % of merchandise exports) of Guatemala and Imports(as % of merchandise exports) of Japan?
Keep it short and to the point. -3.63. In the year 2002, what is the difference between the Imports(as % of merchandise exports) in Honduras and Imports(as % of merchandise exports) in Japan?
Ensure brevity in your answer.  -3.78. In the year 2003, what is the difference between the Imports(as % of merchandise exports) of Sub-Saharan Africa (all income levels) and Imports(as % of merchandise exports) of Guatemala?
Ensure brevity in your answer.  0.54. In the year 2003, what is the difference between the Imports(as % of merchandise exports) in Sub-Saharan Africa (all income levels) and Imports(as % of merchandise exports) in Honduras?
Keep it short and to the point. 0.55. In the year 2003, what is the difference between the Imports(as % of merchandise exports) of Sub-Saharan Africa (all income levels) and Imports(as % of merchandise exports) of Japan?
Give a very brief answer. -3.31. In the year 2003, what is the difference between the Imports(as % of merchandise exports) of Guatemala and Imports(as % of merchandise exports) of Honduras?
Your answer should be very brief. 0.01. In the year 2003, what is the difference between the Imports(as % of merchandise exports) in Guatemala and Imports(as % of merchandise exports) in Japan?
Ensure brevity in your answer.  -3.85. In the year 2003, what is the difference between the Imports(as % of merchandise exports) in Honduras and Imports(as % of merchandise exports) in Japan?
Provide a short and direct response. -3.86. In the year 2004, what is the difference between the Imports(as % of merchandise exports) of Sub-Saharan Africa (all income levels) and Imports(as % of merchandise exports) of Guatemala?
Your answer should be very brief. 0.36. In the year 2004, what is the difference between the Imports(as % of merchandise exports) of Sub-Saharan Africa (all income levels) and Imports(as % of merchandise exports) of Honduras?
Your answer should be compact. 0.76. In the year 2004, what is the difference between the Imports(as % of merchandise exports) in Sub-Saharan Africa (all income levels) and Imports(as % of merchandise exports) in Japan?
Provide a succinct answer. -4.09. In the year 2004, what is the difference between the Imports(as % of merchandise exports) of Guatemala and Imports(as % of merchandise exports) of Honduras?
Keep it short and to the point. 0.41. In the year 2004, what is the difference between the Imports(as % of merchandise exports) of Guatemala and Imports(as % of merchandise exports) of Japan?
Offer a terse response. -4.45. In the year 2004, what is the difference between the Imports(as % of merchandise exports) in Honduras and Imports(as % of merchandise exports) in Japan?
Offer a terse response. -4.86. What is the ratio of the Imports(as % of merchandise exports) of Sub-Saharan Africa (all income levels) in 1997 to that in 1998?
Your response must be concise. 1.01. What is the ratio of the Imports(as % of merchandise exports) of Guatemala in 1997 to that in 1998?
Offer a very short reply. 0.99. What is the ratio of the Imports(as % of merchandise exports) in Honduras in 1997 to that in 1998?
Ensure brevity in your answer.  1.22. What is the ratio of the Imports(as % of merchandise exports) of Sub-Saharan Africa (all income levels) in 1997 to that in 1999?
Offer a terse response. 0.97. What is the ratio of the Imports(as % of merchandise exports) of Guatemala in 1997 to that in 1999?
Provide a short and direct response. 1.11. What is the ratio of the Imports(as % of merchandise exports) of Honduras in 1997 to that in 1999?
Provide a succinct answer. 1.17. What is the ratio of the Imports(as % of merchandise exports) in Japan in 1997 to that in 1999?
Your response must be concise. 1.1. What is the ratio of the Imports(as % of merchandise exports) of Sub-Saharan Africa (all income levels) in 1997 to that in 2000?
Give a very brief answer. 1.06. What is the ratio of the Imports(as % of merchandise exports) of Honduras in 1997 to that in 2000?
Offer a terse response. 1.44. What is the ratio of the Imports(as % of merchandise exports) in Japan in 1997 to that in 2000?
Provide a succinct answer. 1.09. What is the ratio of the Imports(as % of merchandise exports) in Sub-Saharan Africa (all income levels) in 1997 to that in 2001?
Ensure brevity in your answer.  1.13. What is the ratio of the Imports(as % of merchandise exports) of Guatemala in 1997 to that in 2001?
Offer a very short reply. 0.89. What is the ratio of the Imports(as % of merchandise exports) in Honduras in 1997 to that in 2001?
Ensure brevity in your answer.  1.4. What is the ratio of the Imports(as % of merchandise exports) of Japan in 1997 to that in 2001?
Your answer should be very brief. 1.2. What is the ratio of the Imports(as % of merchandise exports) in Sub-Saharan Africa (all income levels) in 1997 to that in 2002?
Your response must be concise. 1.03. What is the ratio of the Imports(as % of merchandise exports) in Guatemala in 1997 to that in 2002?
Your answer should be very brief. 1.09. What is the ratio of the Imports(as % of merchandise exports) of Honduras in 1997 to that in 2002?
Your response must be concise. 1.41. What is the ratio of the Imports(as % of merchandise exports) in Japan in 1997 to that in 2002?
Offer a very short reply. 1.26. What is the ratio of the Imports(as % of merchandise exports) in Sub-Saharan Africa (all income levels) in 1997 to that in 2003?
Your answer should be compact. 0.97. What is the ratio of the Imports(as % of merchandise exports) in Guatemala in 1997 to that in 2003?
Your answer should be compact. 1.18. What is the ratio of the Imports(as % of merchandise exports) in Honduras in 1997 to that in 2003?
Ensure brevity in your answer.  1.33. What is the ratio of the Imports(as % of merchandise exports) in Japan in 1997 to that in 2003?
Offer a very short reply. 1.23. What is the ratio of the Imports(as % of merchandise exports) of Sub-Saharan Africa (all income levels) in 1997 to that in 2004?
Your response must be concise. 0.95. What is the ratio of the Imports(as % of merchandise exports) of Guatemala in 1997 to that in 2004?
Provide a short and direct response. 0.99. What is the ratio of the Imports(as % of merchandise exports) in Honduras in 1997 to that in 2004?
Give a very brief answer. 1.59. What is the ratio of the Imports(as % of merchandise exports) of Japan in 1997 to that in 2004?
Provide a short and direct response. 1.05. What is the ratio of the Imports(as % of merchandise exports) of Sub-Saharan Africa (all income levels) in 1998 to that in 1999?
Keep it short and to the point. 0.96. What is the ratio of the Imports(as % of merchandise exports) in Guatemala in 1998 to that in 1999?
Your answer should be compact. 1.12. What is the ratio of the Imports(as % of merchandise exports) of Honduras in 1998 to that in 1999?
Provide a short and direct response. 0.96. What is the ratio of the Imports(as % of merchandise exports) of Japan in 1998 to that in 1999?
Offer a terse response. 1.09. What is the ratio of the Imports(as % of merchandise exports) in Sub-Saharan Africa (all income levels) in 1998 to that in 2000?
Offer a terse response. 1.05. What is the ratio of the Imports(as % of merchandise exports) in Guatemala in 1998 to that in 2000?
Make the answer very short. 1. What is the ratio of the Imports(as % of merchandise exports) of Honduras in 1998 to that in 2000?
Provide a succinct answer. 1.18. What is the ratio of the Imports(as % of merchandise exports) in Japan in 1998 to that in 2000?
Keep it short and to the point. 1.08. What is the ratio of the Imports(as % of merchandise exports) of Sub-Saharan Africa (all income levels) in 1998 to that in 2001?
Make the answer very short. 1.12. What is the ratio of the Imports(as % of merchandise exports) in Guatemala in 1998 to that in 2001?
Provide a succinct answer. 0.89. What is the ratio of the Imports(as % of merchandise exports) in Honduras in 1998 to that in 2001?
Give a very brief answer. 1.15. What is the ratio of the Imports(as % of merchandise exports) of Japan in 1998 to that in 2001?
Offer a very short reply. 1.19. What is the ratio of the Imports(as % of merchandise exports) in Sub-Saharan Africa (all income levels) in 1998 to that in 2002?
Provide a succinct answer. 1.02. What is the ratio of the Imports(as % of merchandise exports) of Guatemala in 1998 to that in 2002?
Provide a succinct answer. 1.1. What is the ratio of the Imports(as % of merchandise exports) of Honduras in 1998 to that in 2002?
Your answer should be compact. 1.16. What is the ratio of the Imports(as % of merchandise exports) of Japan in 1998 to that in 2002?
Keep it short and to the point. 1.26. What is the ratio of the Imports(as % of merchandise exports) of Sub-Saharan Africa (all income levels) in 1998 to that in 2003?
Ensure brevity in your answer.  0.96. What is the ratio of the Imports(as % of merchandise exports) in Guatemala in 1998 to that in 2003?
Offer a very short reply. 1.19. What is the ratio of the Imports(as % of merchandise exports) of Honduras in 1998 to that in 2003?
Your answer should be very brief. 1.09. What is the ratio of the Imports(as % of merchandise exports) of Japan in 1998 to that in 2003?
Give a very brief answer. 1.22. What is the ratio of the Imports(as % of merchandise exports) in Sub-Saharan Africa (all income levels) in 1998 to that in 2004?
Offer a terse response. 0.94. What is the ratio of the Imports(as % of merchandise exports) of Honduras in 1998 to that in 2004?
Keep it short and to the point. 1.31. What is the ratio of the Imports(as % of merchandise exports) in Japan in 1998 to that in 2004?
Provide a short and direct response. 1.05. What is the ratio of the Imports(as % of merchandise exports) in Sub-Saharan Africa (all income levels) in 1999 to that in 2000?
Give a very brief answer. 1.1. What is the ratio of the Imports(as % of merchandise exports) in Guatemala in 1999 to that in 2000?
Make the answer very short. 0.89. What is the ratio of the Imports(as % of merchandise exports) in Honduras in 1999 to that in 2000?
Give a very brief answer. 1.23. What is the ratio of the Imports(as % of merchandise exports) in Sub-Saharan Africa (all income levels) in 1999 to that in 2001?
Give a very brief answer. 1.17. What is the ratio of the Imports(as % of merchandise exports) in Guatemala in 1999 to that in 2001?
Provide a succinct answer. 0.8. What is the ratio of the Imports(as % of merchandise exports) in Honduras in 1999 to that in 2001?
Make the answer very short. 1.2. What is the ratio of the Imports(as % of merchandise exports) in Japan in 1999 to that in 2001?
Make the answer very short. 1.09. What is the ratio of the Imports(as % of merchandise exports) in Sub-Saharan Africa (all income levels) in 1999 to that in 2002?
Provide a succinct answer. 1.06. What is the ratio of the Imports(as % of merchandise exports) in Honduras in 1999 to that in 2002?
Your answer should be very brief. 1.2. What is the ratio of the Imports(as % of merchandise exports) in Japan in 1999 to that in 2002?
Give a very brief answer. 1.15. What is the ratio of the Imports(as % of merchandise exports) of Sub-Saharan Africa (all income levels) in 1999 to that in 2003?
Your answer should be very brief. 1. What is the ratio of the Imports(as % of merchandise exports) of Guatemala in 1999 to that in 2003?
Keep it short and to the point. 1.06. What is the ratio of the Imports(as % of merchandise exports) of Honduras in 1999 to that in 2003?
Offer a very short reply. 1.14. What is the ratio of the Imports(as % of merchandise exports) in Japan in 1999 to that in 2003?
Your answer should be very brief. 1.12. What is the ratio of the Imports(as % of merchandise exports) in Sub-Saharan Africa (all income levels) in 1999 to that in 2004?
Offer a terse response. 0.98. What is the ratio of the Imports(as % of merchandise exports) in Guatemala in 1999 to that in 2004?
Your response must be concise. 0.89. What is the ratio of the Imports(as % of merchandise exports) in Honduras in 1999 to that in 2004?
Ensure brevity in your answer.  1.36. What is the ratio of the Imports(as % of merchandise exports) of Japan in 1999 to that in 2004?
Your answer should be very brief. 0.96. What is the ratio of the Imports(as % of merchandise exports) of Sub-Saharan Africa (all income levels) in 2000 to that in 2001?
Provide a short and direct response. 1.06. What is the ratio of the Imports(as % of merchandise exports) in Guatemala in 2000 to that in 2001?
Offer a terse response. 0.89. What is the ratio of the Imports(as % of merchandise exports) in Honduras in 2000 to that in 2001?
Provide a short and direct response. 0.97. What is the ratio of the Imports(as % of merchandise exports) in Japan in 2000 to that in 2001?
Make the answer very short. 1.1. What is the ratio of the Imports(as % of merchandise exports) of Sub-Saharan Africa (all income levels) in 2000 to that in 2002?
Ensure brevity in your answer.  0.97. What is the ratio of the Imports(as % of merchandise exports) in Guatemala in 2000 to that in 2002?
Ensure brevity in your answer.  1.1. What is the ratio of the Imports(as % of merchandise exports) of Honduras in 2000 to that in 2002?
Offer a terse response. 0.98. What is the ratio of the Imports(as % of merchandise exports) in Japan in 2000 to that in 2002?
Your answer should be compact. 1.16. What is the ratio of the Imports(as % of merchandise exports) in Sub-Saharan Africa (all income levels) in 2000 to that in 2003?
Ensure brevity in your answer.  0.91. What is the ratio of the Imports(as % of merchandise exports) of Guatemala in 2000 to that in 2003?
Make the answer very short. 1.19. What is the ratio of the Imports(as % of merchandise exports) of Honduras in 2000 to that in 2003?
Your answer should be very brief. 0.93. What is the ratio of the Imports(as % of merchandise exports) of Japan in 2000 to that in 2003?
Your answer should be very brief. 1.13. What is the ratio of the Imports(as % of merchandise exports) of Sub-Saharan Africa (all income levels) in 2000 to that in 2004?
Ensure brevity in your answer.  0.89. What is the ratio of the Imports(as % of merchandise exports) of Honduras in 2000 to that in 2004?
Provide a short and direct response. 1.11. What is the ratio of the Imports(as % of merchandise exports) in Japan in 2000 to that in 2004?
Offer a terse response. 0.97. What is the ratio of the Imports(as % of merchandise exports) in Sub-Saharan Africa (all income levels) in 2001 to that in 2002?
Your answer should be compact. 0.91. What is the ratio of the Imports(as % of merchandise exports) in Guatemala in 2001 to that in 2002?
Ensure brevity in your answer.  1.23. What is the ratio of the Imports(as % of merchandise exports) in Japan in 2001 to that in 2002?
Offer a very short reply. 1.05. What is the ratio of the Imports(as % of merchandise exports) of Sub-Saharan Africa (all income levels) in 2001 to that in 2003?
Provide a succinct answer. 0.86. What is the ratio of the Imports(as % of merchandise exports) in Guatemala in 2001 to that in 2003?
Make the answer very short. 1.33. What is the ratio of the Imports(as % of merchandise exports) of Honduras in 2001 to that in 2003?
Ensure brevity in your answer.  0.95. What is the ratio of the Imports(as % of merchandise exports) of Japan in 2001 to that in 2003?
Ensure brevity in your answer.  1.02. What is the ratio of the Imports(as % of merchandise exports) of Sub-Saharan Africa (all income levels) in 2001 to that in 2004?
Ensure brevity in your answer.  0.84. What is the ratio of the Imports(as % of merchandise exports) of Guatemala in 2001 to that in 2004?
Your response must be concise. 1.11. What is the ratio of the Imports(as % of merchandise exports) of Honduras in 2001 to that in 2004?
Provide a short and direct response. 1.14. What is the ratio of the Imports(as % of merchandise exports) in Japan in 2001 to that in 2004?
Make the answer very short. 0.88. What is the ratio of the Imports(as % of merchandise exports) in Sub-Saharan Africa (all income levels) in 2002 to that in 2003?
Your answer should be compact. 0.95. What is the ratio of the Imports(as % of merchandise exports) in Guatemala in 2002 to that in 2003?
Your answer should be very brief. 1.08. What is the ratio of the Imports(as % of merchandise exports) in Honduras in 2002 to that in 2003?
Make the answer very short. 0.95. What is the ratio of the Imports(as % of merchandise exports) in Japan in 2002 to that in 2003?
Offer a very short reply. 0.97. What is the ratio of the Imports(as % of merchandise exports) of Sub-Saharan Africa (all income levels) in 2002 to that in 2004?
Your response must be concise. 0.92. What is the ratio of the Imports(as % of merchandise exports) of Guatemala in 2002 to that in 2004?
Make the answer very short. 0.9. What is the ratio of the Imports(as % of merchandise exports) in Honduras in 2002 to that in 2004?
Give a very brief answer. 1.13. What is the ratio of the Imports(as % of merchandise exports) of Japan in 2002 to that in 2004?
Your answer should be compact. 0.83. What is the ratio of the Imports(as % of merchandise exports) in Sub-Saharan Africa (all income levels) in 2003 to that in 2004?
Ensure brevity in your answer.  0.98. What is the ratio of the Imports(as % of merchandise exports) in Guatemala in 2003 to that in 2004?
Give a very brief answer. 0.84. What is the ratio of the Imports(as % of merchandise exports) of Honduras in 2003 to that in 2004?
Your response must be concise. 1.19. What is the ratio of the Imports(as % of merchandise exports) of Japan in 2003 to that in 2004?
Give a very brief answer. 0.86. What is the difference between the highest and the second highest Imports(as % of merchandise exports) of Sub-Saharan Africa (all income levels)?
Ensure brevity in your answer.  0.03. What is the difference between the highest and the second highest Imports(as % of merchandise exports) in Guatemala?
Your answer should be very brief. 0.15. What is the difference between the highest and the second highest Imports(as % of merchandise exports) of Honduras?
Ensure brevity in your answer.  0.21. What is the difference between the highest and the second highest Imports(as % of merchandise exports) of Japan?
Keep it short and to the point. 0.04. What is the difference between the highest and the lowest Imports(as % of merchandise exports) in Sub-Saharan Africa (all income levels)?
Make the answer very short. 0.27. What is the difference between the highest and the lowest Imports(as % of merchandise exports) of Guatemala?
Provide a succinct answer. 0.36. What is the difference between the highest and the lowest Imports(as % of merchandise exports) in Honduras?
Your answer should be compact. 0.54. What is the difference between the highest and the lowest Imports(as % of merchandise exports) in Japan?
Offer a terse response. 1.27. 